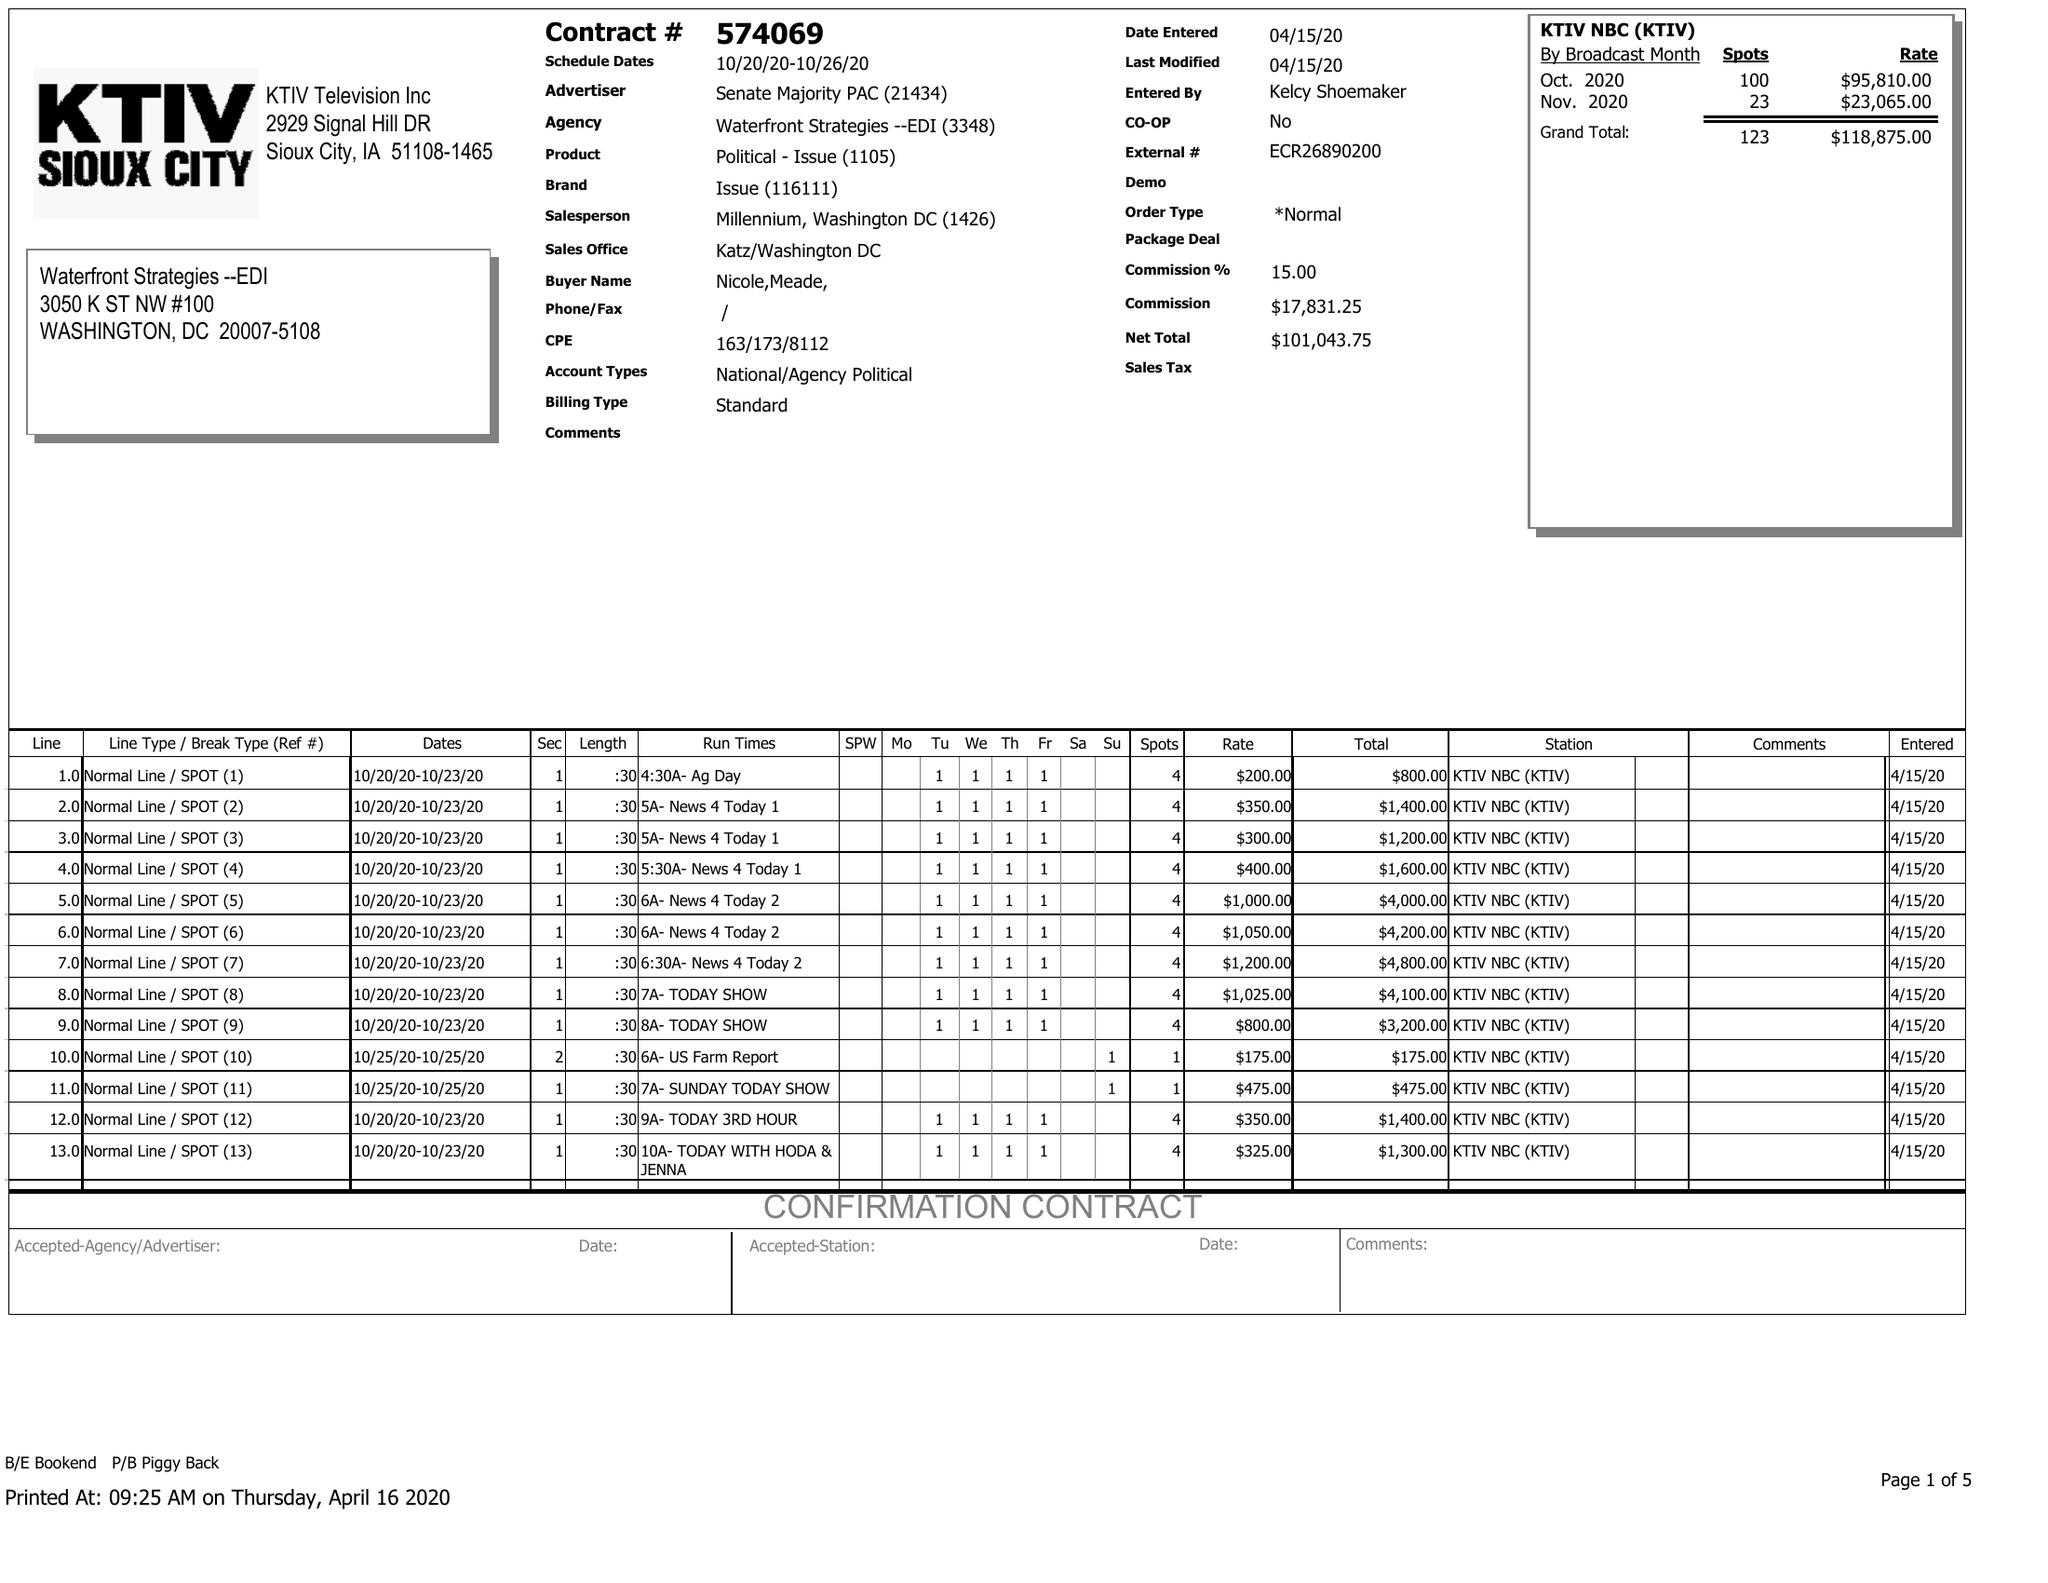What is the value for the contract_num?
Answer the question using a single word or phrase. 574069 